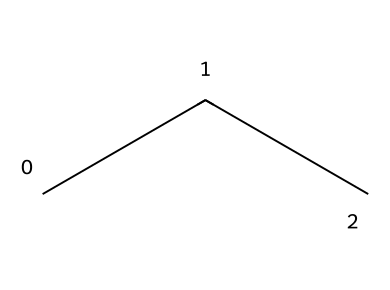How many carbon atoms are in propane (R-290)? The SMILES representation "CCC" indicates that there are three carbon atoms connected in a chain, which signifies that it is propane.
Answer: three What is the molecular formula of propane (R-290)? The structure consists of three carbon atoms and eight hydrogen atoms; hence, the molecular formula derived from the number of atoms is C3H8.
Answer: C3H8 Is propane (R-290) a saturated or unsaturated hydrocarbon? The chemical has only single bonds between all the carbon atoms and between carbon and hydrogen atoms, indicating that it is saturated.
Answer: saturated What is the boiling point of propane (R-290)? Propane is known to have a boiling point of approximately -42 degrees Celsius at standard atmospheric pressure.
Answer: -42 degrees Celsius What type of refrigerant is propane (R-290) classified as? Propane is classified as a natural refrigerant due to its minimal environmental impact and non-synthetic characteristics.
Answer: natural refrigerant Why is propane (R-290) considered an eco-friendly refrigerant? Propane has a low Global Warming Potential (GWP) and does not contribute significantly to ozone depletion, making it environmentally friendly compared to synthetic refrigerants.
Answer: low Global Warming Potential 